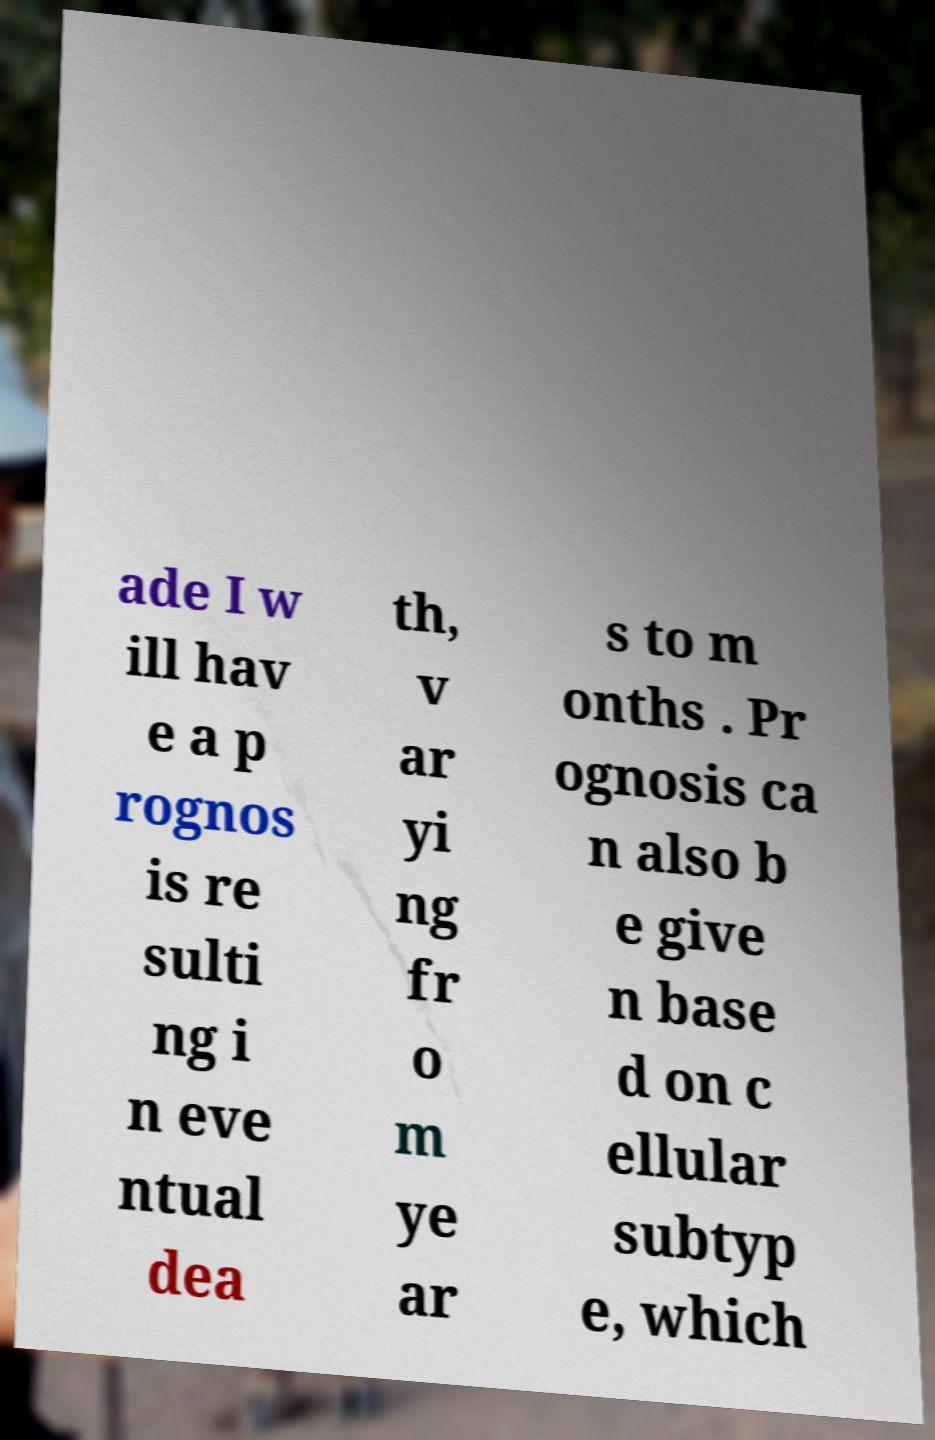Can you read and provide the text displayed in the image?This photo seems to have some interesting text. Can you extract and type it out for me? ade I w ill hav e a p rognos is re sulti ng i n eve ntual dea th, v ar yi ng fr o m ye ar s to m onths . Pr ognosis ca n also b e give n base d on c ellular subtyp e, which 